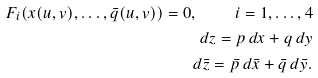<formula> <loc_0><loc_0><loc_500><loc_500>F _ { i } ( x ( u , v ) , \dots , \bar { q } ( u , v ) ) = 0 , \quad i = 1 , \dots , 4 \\ d z = p \, d x + q \, d y \\ d \bar { z } = \bar { p } \, d \bar { x } + \bar { q } \, d \bar { y } .</formula> 